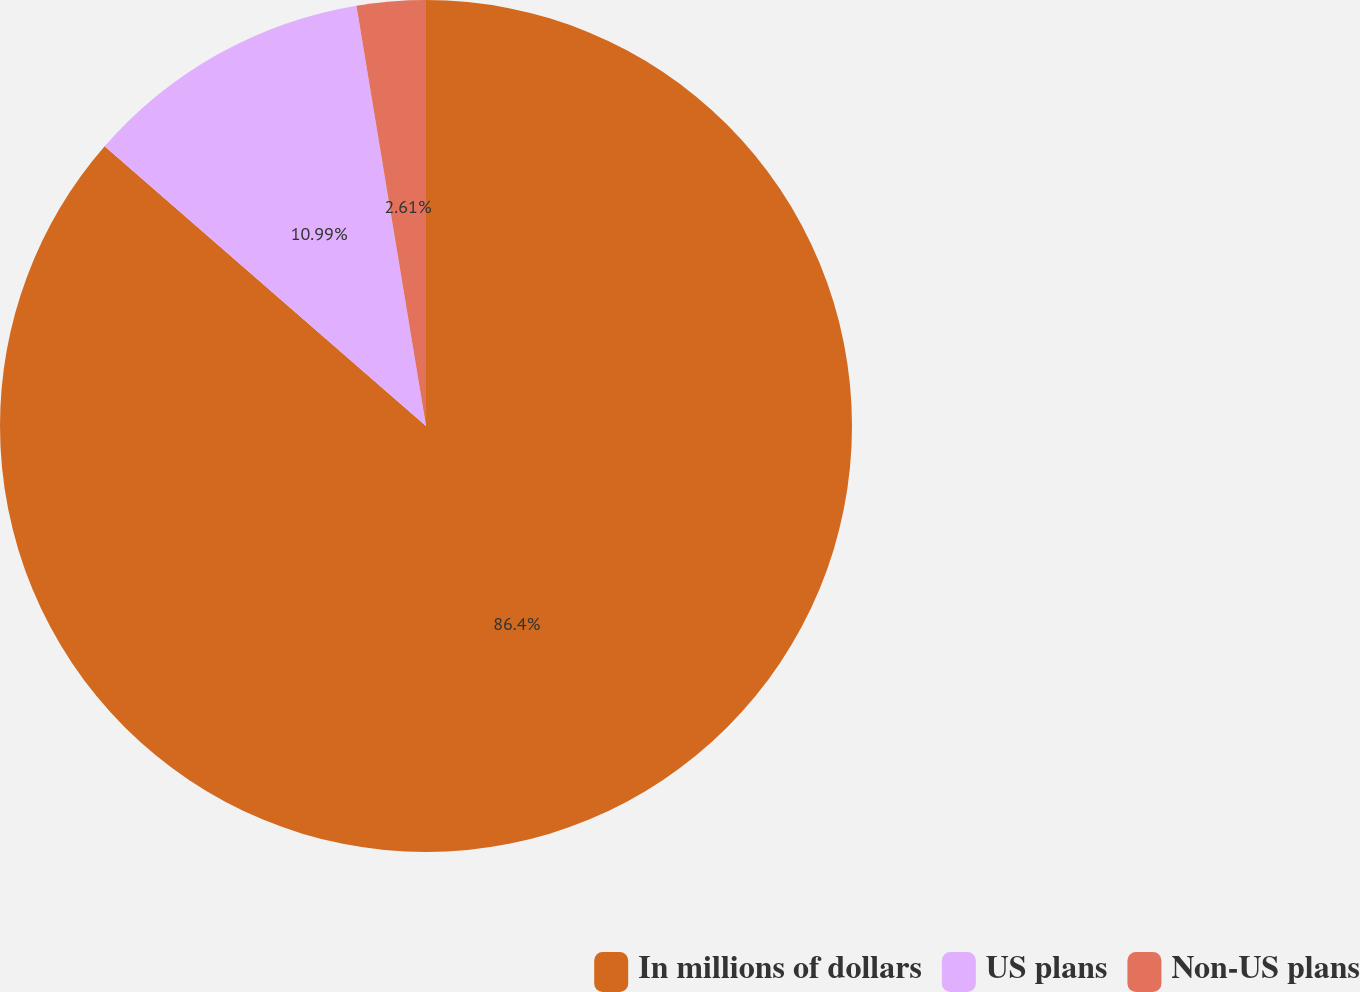Convert chart. <chart><loc_0><loc_0><loc_500><loc_500><pie_chart><fcel>In millions of dollars<fcel>US plans<fcel>Non-US plans<nl><fcel>86.39%<fcel>10.99%<fcel>2.61%<nl></chart> 